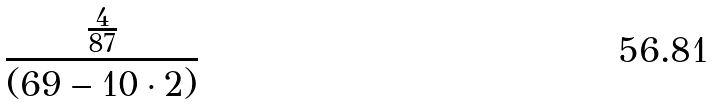Convert formula to latex. <formula><loc_0><loc_0><loc_500><loc_500>\frac { \frac { 4 } { 8 7 } } { ( 6 9 - 1 0 \cdot 2 ) }</formula> 